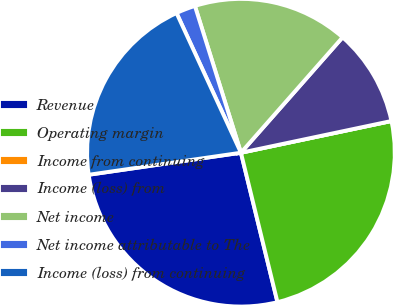Convert chart to OTSL. <chart><loc_0><loc_0><loc_500><loc_500><pie_chart><fcel>Revenue<fcel>Operating margin<fcel>Income from continuing<fcel>Income (loss) from<fcel>Net income<fcel>Net income attributable to The<fcel>Income (loss) from continuing<nl><fcel>26.53%<fcel>24.49%<fcel>0.0%<fcel>10.2%<fcel>16.33%<fcel>2.04%<fcel>20.41%<nl></chart> 